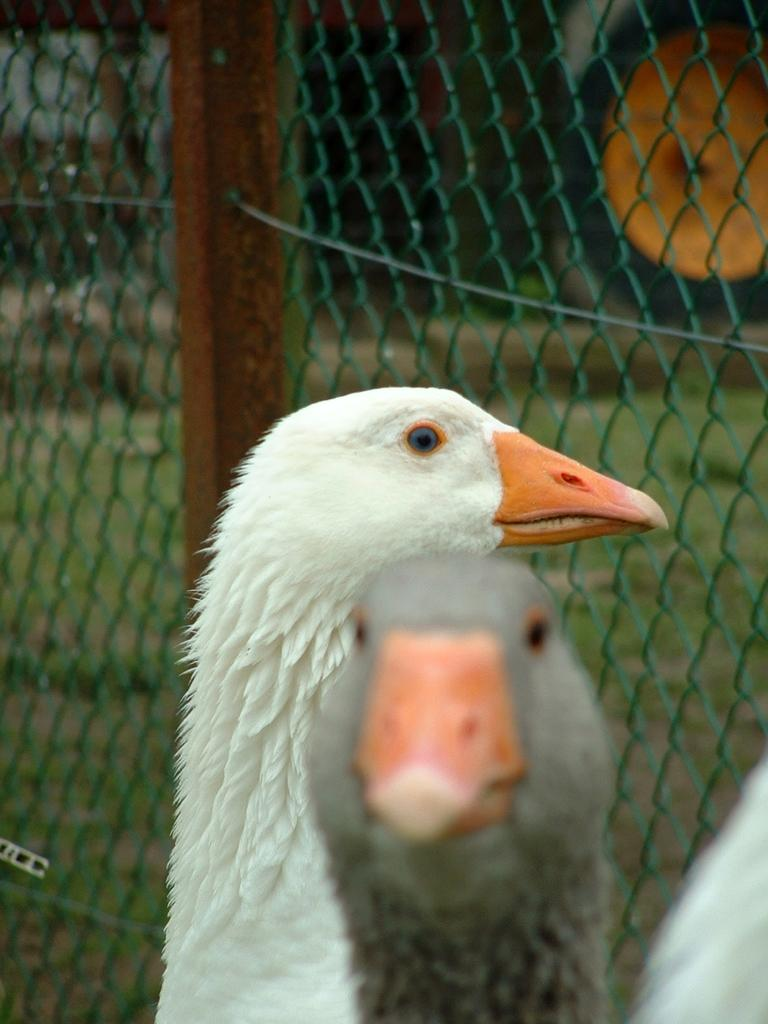What type of animals can be seen in the image? There are birds in the image. What is the purpose of the structure visible in the image? The fencing in the image serves as a barrier or enclosure. What type of vegetation is visible on the ground in the image? Grass is visible on the ground through the fencing. What can be seen in the background of the image? There are objects in the background of the image. What type of crook is visible in the image? There is no crook present in the image. Can you tell me how many doors are visible in the image? There are no doors visible in the image. 